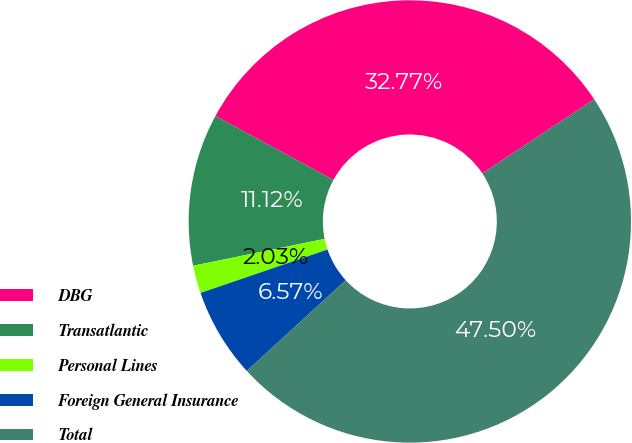Convert chart to OTSL. <chart><loc_0><loc_0><loc_500><loc_500><pie_chart><fcel>DBG<fcel>Transatlantic<fcel>Personal Lines<fcel>Foreign General Insurance<fcel>Total<nl><fcel>32.77%<fcel>11.12%<fcel>2.03%<fcel>6.57%<fcel>47.5%<nl></chart> 